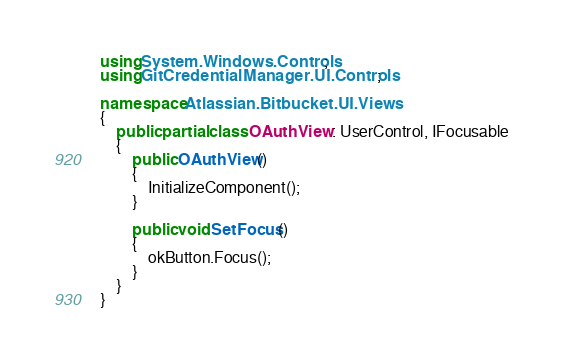Convert code to text. <code><loc_0><loc_0><loc_500><loc_500><_C#_>using System.Windows.Controls;
using GitCredentialManager.UI.Controls;

namespace Atlassian.Bitbucket.UI.Views
{
    public partial class OAuthView : UserControl, IFocusable
    {
        public OAuthView()
        {
            InitializeComponent();
        }

        public void SetFocus()
        {
            okButton.Focus();
        }
    }
}
</code> 